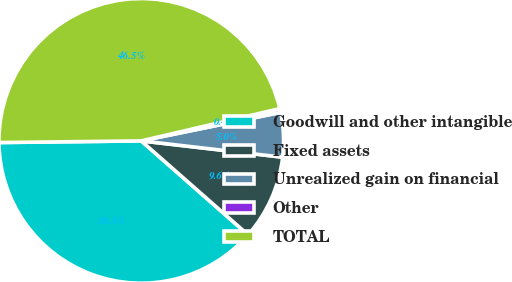Convert chart to OTSL. <chart><loc_0><loc_0><loc_500><loc_500><pie_chart><fcel>Goodwill and other intangible<fcel>Fixed assets<fcel>Unrealized gain on financial<fcel>Other<fcel>TOTAL<nl><fcel>38.34%<fcel>9.65%<fcel>5.04%<fcel>0.43%<fcel>46.55%<nl></chart> 